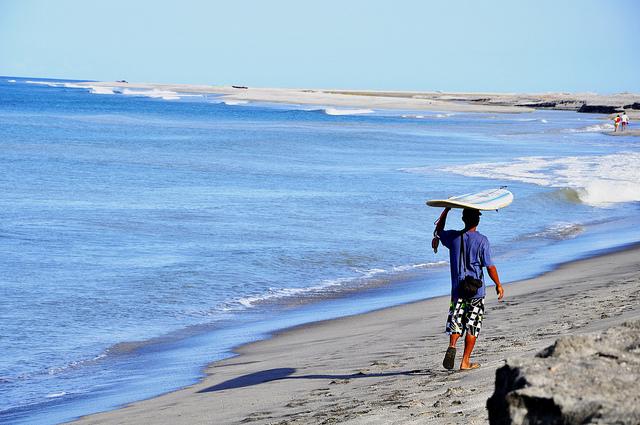How many waves are hitting the beach?
Be succinct. 1. What is on the left hand?
Write a very short answer. Surfboard. What is on the ground?
Keep it brief. Sand. Is the man carrying a boat on his head?
Be succinct. No. Where is the surfboard?
Be succinct. On man's head. What are they standing on?
Keep it brief. Sand. 